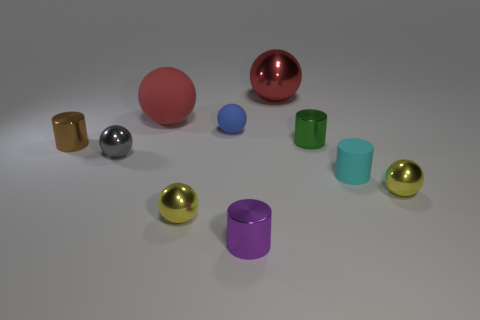Subtract all tiny green shiny cylinders. How many cylinders are left? 3 Subtract all balls. How many objects are left? 4 Subtract 0 green blocks. How many objects are left? 10 Subtract 4 spheres. How many spheres are left? 2 Subtract all yellow balls. Subtract all purple cylinders. How many balls are left? 4 Subtract all purple balls. How many cyan cylinders are left? 1 Subtract all large yellow rubber balls. Subtract all tiny brown metal cylinders. How many objects are left? 9 Add 7 small yellow metal spheres. How many small yellow metal spheres are left? 9 Add 3 large matte objects. How many large matte objects exist? 4 Subtract all blue balls. How many balls are left? 5 